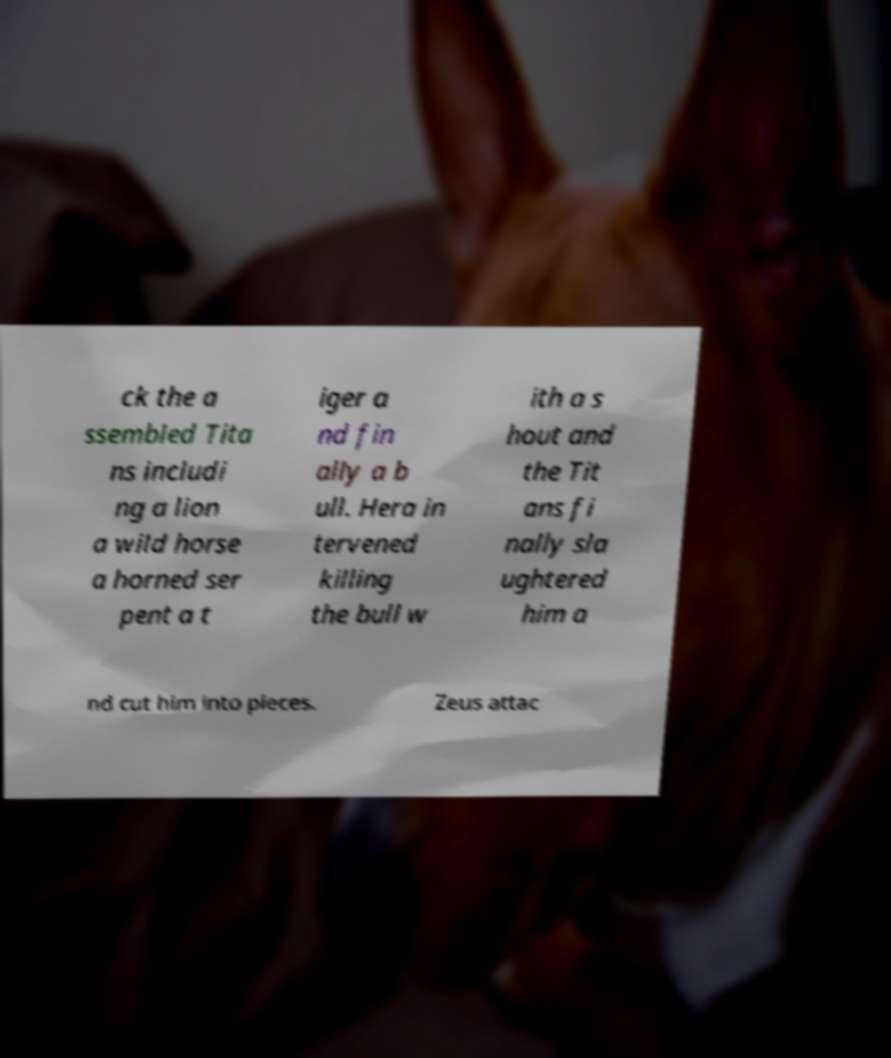Please read and relay the text visible in this image. What does it say? ck the a ssembled Tita ns includi ng a lion a wild horse a horned ser pent a t iger a nd fin ally a b ull. Hera in tervened killing the bull w ith a s hout and the Tit ans fi nally sla ughtered him a nd cut him into pieces. Zeus attac 